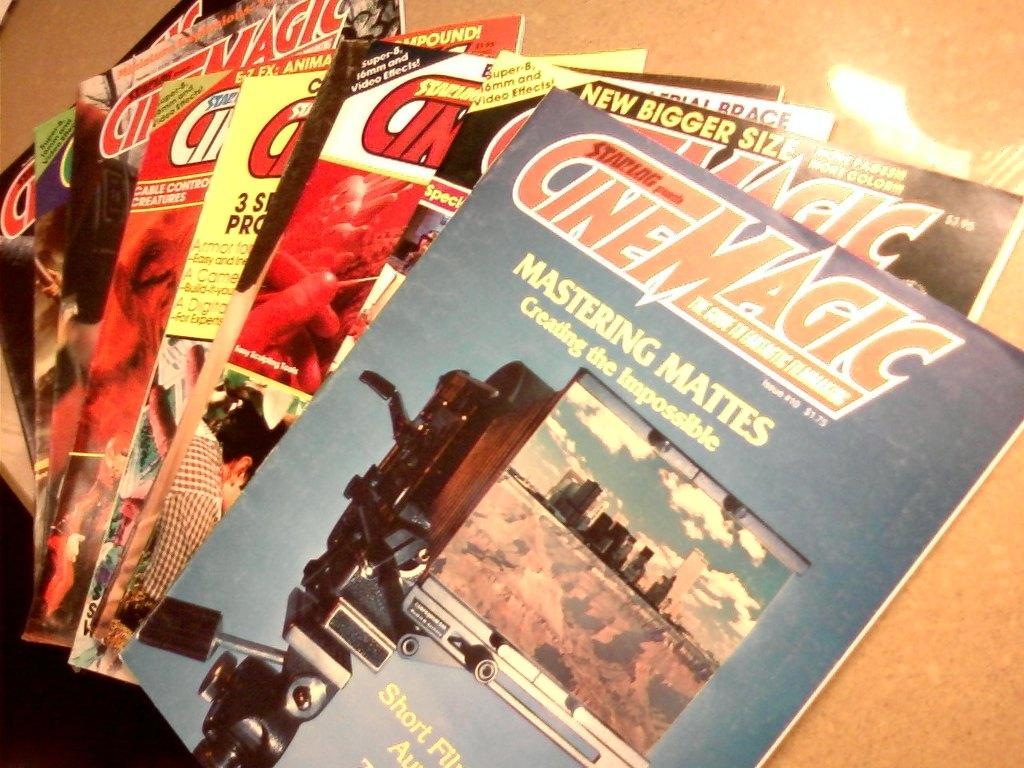<image>
Create a compact narrative representing the image presented. Some CineMagic magazines are strewn across a table. 